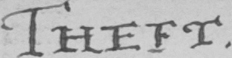What text is written in this handwritten line? THEFT . 